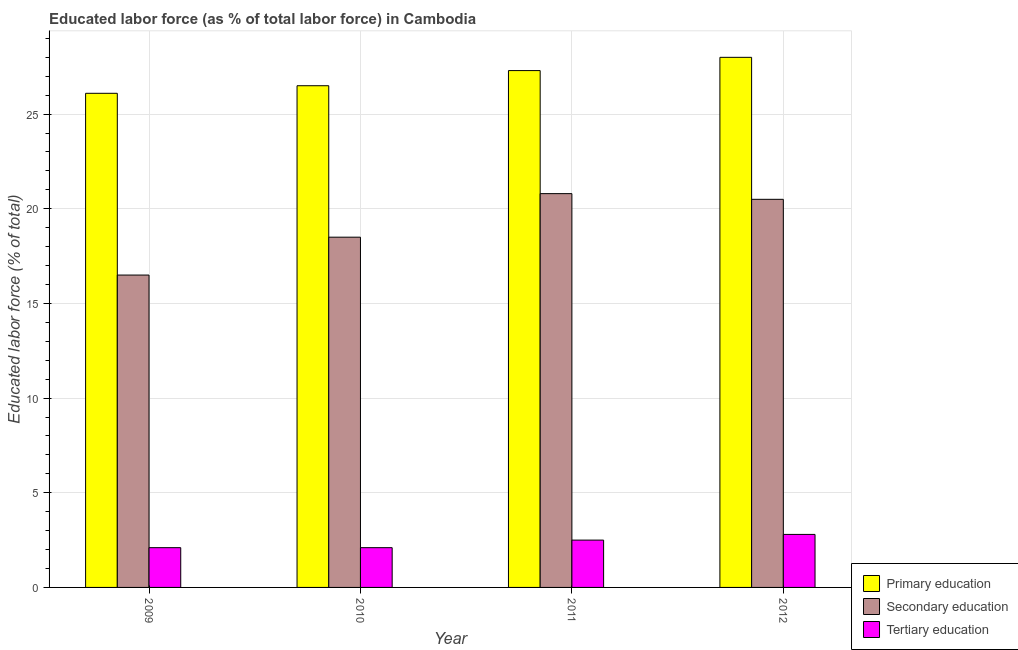What is the label of the 2nd group of bars from the left?
Your answer should be very brief. 2010. In how many cases, is the number of bars for a given year not equal to the number of legend labels?
Provide a succinct answer. 0. What is the percentage of labor force who received tertiary education in 2010?
Ensure brevity in your answer.  2.1. Across all years, what is the maximum percentage of labor force who received tertiary education?
Provide a short and direct response. 2.8. Across all years, what is the minimum percentage of labor force who received tertiary education?
Provide a short and direct response. 2.1. In which year was the percentage of labor force who received secondary education maximum?
Give a very brief answer. 2011. What is the total percentage of labor force who received primary education in the graph?
Offer a terse response. 107.9. What is the difference between the percentage of labor force who received primary education in 2010 and that in 2011?
Provide a succinct answer. -0.8. What is the difference between the percentage of labor force who received secondary education in 2010 and the percentage of labor force who received primary education in 2011?
Give a very brief answer. -2.3. What is the average percentage of labor force who received secondary education per year?
Your answer should be compact. 19.07. In the year 2012, what is the difference between the percentage of labor force who received primary education and percentage of labor force who received tertiary education?
Give a very brief answer. 0. In how many years, is the percentage of labor force who received tertiary education greater than 11 %?
Give a very brief answer. 0. What is the ratio of the percentage of labor force who received tertiary education in 2009 to that in 2012?
Offer a very short reply. 0.75. Is the difference between the percentage of labor force who received primary education in 2009 and 2010 greater than the difference between the percentage of labor force who received secondary education in 2009 and 2010?
Ensure brevity in your answer.  No. What is the difference between the highest and the second highest percentage of labor force who received tertiary education?
Your answer should be compact. 0.3. What is the difference between the highest and the lowest percentage of labor force who received primary education?
Keep it short and to the point. 1.9. In how many years, is the percentage of labor force who received tertiary education greater than the average percentage of labor force who received tertiary education taken over all years?
Offer a terse response. 2. What does the 1st bar from the left in 2011 represents?
Keep it short and to the point. Primary education. What does the 3rd bar from the right in 2010 represents?
Give a very brief answer. Primary education. Is it the case that in every year, the sum of the percentage of labor force who received primary education and percentage of labor force who received secondary education is greater than the percentage of labor force who received tertiary education?
Offer a terse response. Yes. How many bars are there?
Provide a succinct answer. 12. How many years are there in the graph?
Provide a short and direct response. 4. Are the values on the major ticks of Y-axis written in scientific E-notation?
Give a very brief answer. No. Does the graph contain grids?
Provide a short and direct response. Yes. How many legend labels are there?
Give a very brief answer. 3. How are the legend labels stacked?
Provide a succinct answer. Vertical. What is the title of the graph?
Offer a terse response. Educated labor force (as % of total labor force) in Cambodia. What is the label or title of the X-axis?
Your response must be concise. Year. What is the label or title of the Y-axis?
Keep it short and to the point. Educated labor force (% of total). What is the Educated labor force (% of total) in Primary education in 2009?
Your answer should be compact. 26.1. What is the Educated labor force (% of total) in Secondary education in 2009?
Offer a very short reply. 16.5. What is the Educated labor force (% of total) of Tertiary education in 2009?
Make the answer very short. 2.1. What is the Educated labor force (% of total) of Tertiary education in 2010?
Your response must be concise. 2.1. What is the Educated labor force (% of total) in Primary education in 2011?
Offer a very short reply. 27.3. What is the Educated labor force (% of total) of Secondary education in 2011?
Your answer should be very brief. 20.8. What is the Educated labor force (% of total) of Tertiary education in 2011?
Make the answer very short. 2.5. What is the Educated labor force (% of total) in Primary education in 2012?
Make the answer very short. 28. What is the Educated labor force (% of total) of Secondary education in 2012?
Ensure brevity in your answer.  20.5. What is the Educated labor force (% of total) in Tertiary education in 2012?
Your answer should be very brief. 2.8. Across all years, what is the maximum Educated labor force (% of total) of Primary education?
Make the answer very short. 28. Across all years, what is the maximum Educated labor force (% of total) of Secondary education?
Keep it short and to the point. 20.8. Across all years, what is the maximum Educated labor force (% of total) in Tertiary education?
Keep it short and to the point. 2.8. Across all years, what is the minimum Educated labor force (% of total) of Primary education?
Offer a terse response. 26.1. Across all years, what is the minimum Educated labor force (% of total) in Tertiary education?
Offer a very short reply. 2.1. What is the total Educated labor force (% of total) in Primary education in the graph?
Offer a terse response. 107.9. What is the total Educated labor force (% of total) of Secondary education in the graph?
Your response must be concise. 76.3. What is the difference between the Educated labor force (% of total) in Secondary education in 2009 and that in 2010?
Offer a terse response. -2. What is the difference between the Educated labor force (% of total) of Primary education in 2009 and that in 2011?
Provide a succinct answer. -1.2. What is the difference between the Educated labor force (% of total) in Tertiary education in 2009 and that in 2012?
Your response must be concise. -0.7. What is the difference between the Educated labor force (% of total) in Primary education in 2010 and that in 2011?
Ensure brevity in your answer.  -0.8. What is the difference between the Educated labor force (% of total) in Secondary education in 2010 and that in 2011?
Offer a terse response. -2.3. What is the difference between the Educated labor force (% of total) in Tertiary education in 2010 and that in 2011?
Your response must be concise. -0.4. What is the difference between the Educated labor force (% of total) of Tertiary education in 2010 and that in 2012?
Ensure brevity in your answer.  -0.7. What is the difference between the Educated labor force (% of total) of Primary education in 2011 and that in 2012?
Your answer should be very brief. -0.7. What is the difference between the Educated labor force (% of total) of Tertiary education in 2011 and that in 2012?
Offer a very short reply. -0.3. What is the difference between the Educated labor force (% of total) in Primary education in 2009 and the Educated labor force (% of total) in Tertiary education in 2010?
Provide a succinct answer. 24. What is the difference between the Educated labor force (% of total) of Secondary education in 2009 and the Educated labor force (% of total) of Tertiary education in 2010?
Keep it short and to the point. 14.4. What is the difference between the Educated labor force (% of total) in Primary education in 2009 and the Educated labor force (% of total) in Tertiary education in 2011?
Make the answer very short. 23.6. What is the difference between the Educated labor force (% of total) of Secondary education in 2009 and the Educated labor force (% of total) of Tertiary education in 2011?
Provide a succinct answer. 14. What is the difference between the Educated labor force (% of total) in Primary education in 2009 and the Educated labor force (% of total) in Secondary education in 2012?
Ensure brevity in your answer.  5.6. What is the difference between the Educated labor force (% of total) in Primary education in 2009 and the Educated labor force (% of total) in Tertiary education in 2012?
Make the answer very short. 23.3. What is the difference between the Educated labor force (% of total) in Primary education in 2010 and the Educated labor force (% of total) in Secondary education in 2011?
Provide a succinct answer. 5.7. What is the difference between the Educated labor force (% of total) in Primary education in 2010 and the Educated labor force (% of total) in Tertiary education in 2012?
Provide a short and direct response. 23.7. What is the difference between the Educated labor force (% of total) of Secondary education in 2010 and the Educated labor force (% of total) of Tertiary education in 2012?
Ensure brevity in your answer.  15.7. What is the difference between the Educated labor force (% of total) in Primary education in 2011 and the Educated labor force (% of total) in Secondary education in 2012?
Give a very brief answer. 6.8. What is the difference between the Educated labor force (% of total) in Primary education in 2011 and the Educated labor force (% of total) in Tertiary education in 2012?
Provide a short and direct response. 24.5. What is the difference between the Educated labor force (% of total) in Secondary education in 2011 and the Educated labor force (% of total) in Tertiary education in 2012?
Give a very brief answer. 18. What is the average Educated labor force (% of total) in Primary education per year?
Keep it short and to the point. 26.98. What is the average Educated labor force (% of total) in Secondary education per year?
Offer a terse response. 19.07. What is the average Educated labor force (% of total) in Tertiary education per year?
Offer a terse response. 2.38. In the year 2010, what is the difference between the Educated labor force (% of total) in Primary education and Educated labor force (% of total) in Tertiary education?
Your answer should be compact. 24.4. In the year 2011, what is the difference between the Educated labor force (% of total) in Primary education and Educated labor force (% of total) in Secondary education?
Offer a very short reply. 6.5. In the year 2011, what is the difference between the Educated labor force (% of total) of Primary education and Educated labor force (% of total) of Tertiary education?
Your answer should be very brief. 24.8. In the year 2011, what is the difference between the Educated labor force (% of total) in Secondary education and Educated labor force (% of total) in Tertiary education?
Provide a short and direct response. 18.3. In the year 2012, what is the difference between the Educated labor force (% of total) in Primary education and Educated labor force (% of total) in Tertiary education?
Your response must be concise. 25.2. In the year 2012, what is the difference between the Educated labor force (% of total) in Secondary education and Educated labor force (% of total) in Tertiary education?
Offer a terse response. 17.7. What is the ratio of the Educated labor force (% of total) in Primary education in 2009 to that in 2010?
Offer a very short reply. 0.98. What is the ratio of the Educated labor force (% of total) of Secondary education in 2009 to that in 2010?
Ensure brevity in your answer.  0.89. What is the ratio of the Educated labor force (% of total) of Primary education in 2009 to that in 2011?
Offer a very short reply. 0.96. What is the ratio of the Educated labor force (% of total) in Secondary education in 2009 to that in 2011?
Your response must be concise. 0.79. What is the ratio of the Educated labor force (% of total) of Tertiary education in 2009 to that in 2011?
Keep it short and to the point. 0.84. What is the ratio of the Educated labor force (% of total) in Primary education in 2009 to that in 2012?
Provide a succinct answer. 0.93. What is the ratio of the Educated labor force (% of total) in Secondary education in 2009 to that in 2012?
Offer a very short reply. 0.8. What is the ratio of the Educated labor force (% of total) in Tertiary education in 2009 to that in 2012?
Keep it short and to the point. 0.75. What is the ratio of the Educated labor force (% of total) of Primary education in 2010 to that in 2011?
Ensure brevity in your answer.  0.97. What is the ratio of the Educated labor force (% of total) of Secondary education in 2010 to that in 2011?
Offer a very short reply. 0.89. What is the ratio of the Educated labor force (% of total) of Tertiary education in 2010 to that in 2011?
Offer a terse response. 0.84. What is the ratio of the Educated labor force (% of total) in Primary education in 2010 to that in 2012?
Your answer should be very brief. 0.95. What is the ratio of the Educated labor force (% of total) of Secondary education in 2010 to that in 2012?
Offer a terse response. 0.9. What is the ratio of the Educated labor force (% of total) in Primary education in 2011 to that in 2012?
Make the answer very short. 0.97. What is the ratio of the Educated labor force (% of total) in Secondary education in 2011 to that in 2012?
Offer a very short reply. 1.01. What is the ratio of the Educated labor force (% of total) in Tertiary education in 2011 to that in 2012?
Your response must be concise. 0.89. What is the difference between the highest and the second highest Educated labor force (% of total) of Primary education?
Give a very brief answer. 0.7. What is the difference between the highest and the second highest Educated labor force (% of total) of Tertiary education?
Ensure brevity in your answer.  0.3. What is the difference between the highest and the lowest Educated labor force (% of total) of Secondary education?
Ensure brevity in your answer.  4.3. 